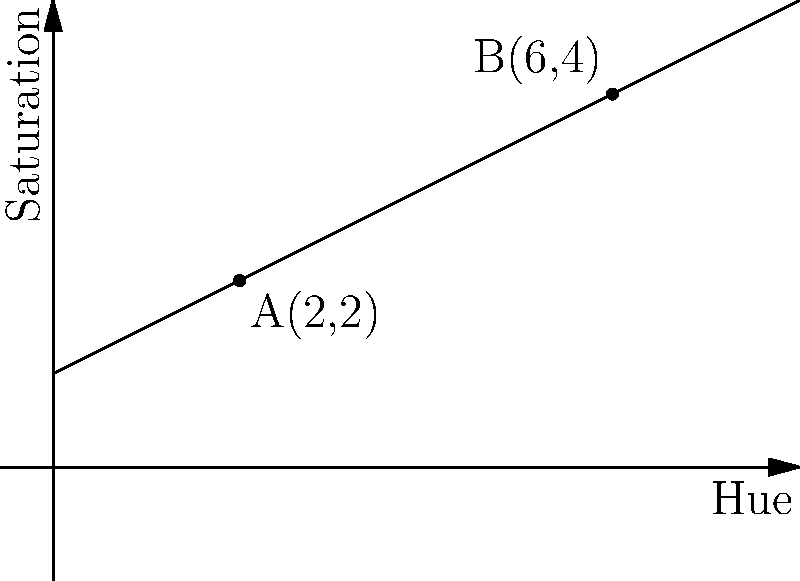As a graphic designer studying color influence on consumer behavior, you're analyzing the relationship between hue and saturation in a marketing campaign. The graph shows the change in saturation across different hues. Points A(2,2) and B(6,4) represent two color samples. Calculate the slope of the line segment AB and interpret its meaning in terms of color saturation change. To solve this problem, we'll follow these steps:

1) Recall the slope formula: $m = \frac{y_2 - y_1}{x_2 - x_1}$

2) Identify the coordinates:
   Point A: $(x_1, y_1) = (2, 2)$
   Point B: $(x_2, y_2) = (6, 4)$

3) Plug these values into the slope formula:

   $m = \frac{4 - 2}{6 - 2} = \frac{2}{4} = 0.5$

4) Interpret the result:
   The slope of 0.5 means that for every 1 unit increase in hue, the saturation increases by 0.5 units.

5) In color theory context:
   This positive slope indicates that as we move from color A to B, the saturation is increasing. Specifically, for every 1 unit change in hue, the saturation increases by 0.5 units. This suggests a gradual increase in color intensity or purity as we move along the hue spectrum between these two color samples.
Answer: Slope = 0.5; For every 1 unit increase in hue, saturation increases by 0.5 units. 